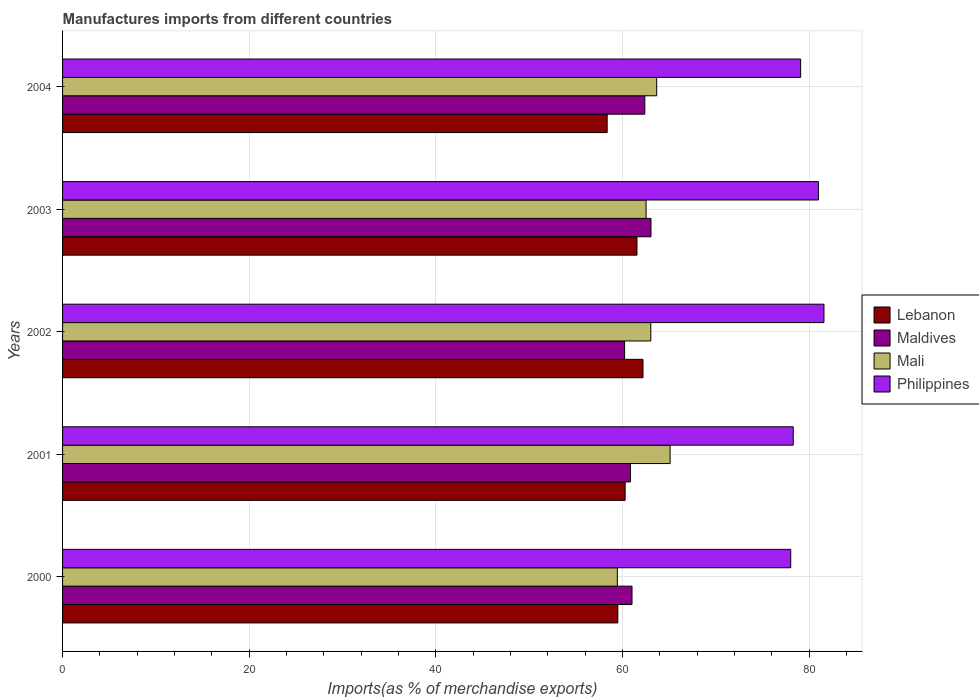How many different coloured bars are there?
Make the answer very short. 4. How many bars are there on the 3rd tick from the bottom?
Your answer should be very brief. 4. What is the percentage of imports to different countries in Mali in 2003?
Your response must be concise. 62.52. Across all years, what is the maximum percentage of imports to different countries in Lebanon?
Your answer should be very brief. 62.19. Across all years, what is the minimum percentage of imports to different countries in Mali?
Offer a terse response. 59.44. In which year was the percentage of imports to different countries in Maldives maximum?
Make the answer very short. 2003. What is the total percentage of imports to different countries in Mali in the graph?
Ensure brevity in your answer.  313.72. What is the difference between the percentage of imports to different countries in Maldives in 2000 and that in 2004?
Provide a short and direct response. -1.37. What is the difference between the percentage of imports to different countries in Philippines in 2003 and the percentage of imports to different countries in Mali in 2002?
Provide a short and direct response. 17.96. What is the average percentage of imports to different countries in Lebanon per year?
Offer a terse response. 60.37. In the year 2002, what is the difference between the percentage of imports to different countries in Philippines and percentage of imports to different countries in Maldives?
Provide a succinct answer. 21.36. In how many years, is the percentage of imports to different countries in Philippines greater than 64 %?
Offer a terse response. 5. What is the ratio of the percentage of imports to different countries in Maldives in 2001 to that in 2004?
Give a very brief answer. 0.98. Is the percentage of imports to different countries in Lebanon in 2001 less than that in 2003?
Your answer should be very brief. Yes. What is the difference between the highest and the second highest percentage of imports to different countries in Lebanon?
Provide a succinct answer. 0.65. What is the difference between the highest and the lowest percentage of imports to different countries in Maldives?
Offer a very short reply. 2.82. What does the 4th bar from the top in 2002 represents?
Make the answer very short. Lebanon. What does the 3rd bar from the bottom in 2002 represents?
Provide a short and direct response. Mali. Are all the bars in the graph horizontal?
Make the answer very short. Yes. Does the graph contain any zero values?
Your answer should be compact. No. Does the graph contain grids?
Ensure brevity in your answer.  Yes. Where does the legend appear in the graph?
Your answer should be very brief. Center right. How many legend labels are there?
Provide a short and direct response. 4. How are the legend labels stacked?
Your answer should be very brief. Vertical. What is the title of the graph?
Your answer should be very brief. Manufactures imports from different countries. Does "Least developed countries" appear as one of the legend labels in the graph?
Your answer should be very brief. No. What is the label or title of the X-axis?
Give a very brief answer. Imports(as % of merchandise exports). What is the Imports(as % of merchandise exports) in Lebanon in 2000?
Your answer should be compact. 59.49. What is the Imports(as % of merchandise exports) of Maldives in 2000?
Offer a terse response. 61.01. What is the Imports(as % of merchandise exports) of Mali in 2000?
Give a very brief answer. 59.44. What is the Imports(as % of merchandise exports) in Philippines in 2000?
Your answer should be very brief. 78.01. What is the Imports(as % of merchandise exports) in Lebanon in 2001?
Ensure brevity in your answer.  60.27. What is the Imports(as % of merchandise exports) of Maldives in 2001?
Ensure brevity in your answer.  60.84. What is the Imports(as % of merchandise exports) in Mali in 2001?
Ensure brevity in your answer.  65.09. What is the Imports(as % of merchandise exports) of Philippines in 2001?
Give a very brief answer. 78.28. What is the Imports(as % of merchandise exports) of Lebanon in 2002?
Provide a short and direct response. 62.19. What is the Imports(as % of merchandise exports) of Maldives in 2002?
Make the answer very short. 60.22. What is the Imports(as % of merchandise exports) in Mali in 2002?
Provide a short and direct response. 63.02. What is the Imports(as % of merchandise exports) in Philippines in 2002?
Provide a short and direct response. 81.57. What is the Imports(as % of merchandise exports) in Lebanon in 2003?
Offer a terse response. 61.54. What is the Imports(as % of merchandise exports) of Maldives in 2003?
Provide a short and direct response. 63.04. What is the Imports(as % of merchandise exports) in Mali in 2003?
Provide a short and direct response. 62.52. What is the Imports(as % of merchandise exports) of Philippines in 2003?
Make the answer very short. 80.98. What is the Imports(as % of merchandise exports) of Lebanon in 2004?
Your answer should be very brief. 58.35. What is the Imports(as % of merchandise exports) in Maldives in 2004?
Keep it short and to the point. 62.38. What is the Imports(as % of merchandise exports) in Mali in 2004?
Your answer should be very brief. 63.65. What is the Imports(as % of merchandise exports) in Philippines in 2004?
Your answer should be very brief. 79.07. Across all years, what is the maximum Imports(as % of merchandise exports) of Lebanon?
Offer a very short reply. 62.19. Across all years, what is the maximum Imports(as % of merchandise exports) in Maldives?
Your answer should be very brief. 63.04. Across all years, what is the maximum Imports(as % of merchandise exports) in Mali?
Give a very brief answer. 65.09. Across all years, what is the maximum Imports(as % of merchandise exports) in Philippines?
Provide a succinct answer. 81.57. Across all years, what is the minimum Imports(as % of merchandise exports) in Lebanon?
Your response must be concise. 58.35. Across all years, what is the minimum Imports(as % of merchandise exports) of Maldives?
Offer a terse response. 60.22. Across all years, what is the minimum Imports(as % of merchandise exports) in Mali?
Make the answer very short. 59.44. Across all years, what is the minimum Imports(as % of merchandise exports) of Philippines?
Offer a very short reply. 78.01. What is the total Imports(as % of merchandise exports) of Lebanon in the graph?
Provide a succinct answer. 301.83. What is the total Imports(as % of merchandise exports) in Maldives in the graph?
Give a very brief answer. 307.48. What is the total Imports(as % of merchandise exports) in Mali in the graph?
Make the answer very short. 313.72. What is the total Imports(as % of merchandise exports) of Philippines in the graph?
Ensure brevity in your answer.  397.92. What is the difference between the Imports(as % of merchandise exports) in Lebanon in 2000 and that in 2001?
Offer a terse response. -0.78. What is the difference between the Imports(as % of merchandise exports) of Maldives in 2000 and that in 2001?
Make the answer very short. 0.17. What is the difference between the Imports(as % of merchandise exports) in Mali in 2000 and that in 2001?
Ensure brevity in your answer.  -5.65. What is the difference between the Imports(as % of merchandise exports) in Philippines in 2000 and that in 2001?
Your response must be concise. -0.27. What is the difference between the Imports(as % of merchandise exports) of Lebanon in 2000 and that in 2002?
Keep it short and to the point. -2.7. What is the difference between the Imports(as % of merchandise exports) in Maldives in 2000 and that in 2002?
Provide a short and direct response. 0.79. What is the difference between the Imports(as % of merchandise exports) in Mali in 2000 and that in 2002?
Provide a short and direct response. -3.59. What is the difference between the Imports(as % of merchandise exports) in Philippines in 2000 and that in 2002?
Give a very brief answer. -3.56. What is the difference between the Imports(as % of merchandise exports) of Lebanon in 2000 and that in 2003?
Provide a succinct answer. -2.05. What is the difference between the Imports(as % of merchandise exports) in Maldives in 2000 and that in 2003?
Provide a succinct answer. -2.03. What is the difference between the Imports(as % of merchandise exports) of Mali in 2000 and that in 2003?
Ensure brevity in your answer.  -3.08. What is the difference between the Imports(as % of merchandise exports) in Philippines in 2000 and that in 2003?
Your answer should be compact. -2.97. What is the difference between the Imports(as % of merchandise exports) of Lebanon in 2000 and that in 2004?
Offer a very short reply. 1.14. What is the difference between the Imports(as % of merchandise exports) in Maldives in 2000 and that in 2004?
Keep it short and to the point. -1.37. What is the difference between the Imports(as % of merchandise exports) in Mali in 2000 and that in 2004?
Provide a succinct answer. -4.22. What is the difference between the Imports(as % of merchandise exports) of Philippines in 2000 and that in 2004?
Make the answer very short. -1.06. What is the difference between the Imports(as % of merchandise exports) of Lebanon in 2001 and that in 2002?
Ensure brevity in your answer.  -1.92. What is the difference between the Imports(as % of merchandise exports) in Maldives in 2001 and that in 2002?
Ensure brevity in your answer.  0.62. What is the difference between the Imports(as % of merchandise exports) of Mali in 2001 and that in 2002?
Provide a succinct answer. 2.07. What is the difference between the Imports(as % of merchandise exports) of Philippines in 2001 and that in 2002?
Provide a succinct answer. -3.29. What is the difference between the Imports(as % of merchandise exports) of Lebanon in 2001 and that in 2003?
Give a very brief answer. -1.27. What is the difference between the Imports(as % of merchandise exports) in Maldives in 2001 and that in 2003?
Offer a very short reply. -2.2. What is the difference between the Imports(as % of merchandise exports) in Mali in 2001 and that in 2003?
Keep it short and to the point. 2.57. What is the difference between the Imports(as % of merchandise exports) in Philippines in 2001 and that in 2003?
Keep it short and to the point. -2.7. What is the difference between the Imports(as % of merchandise exports) of Lebanon in 2001 and that in 2004?
Keep it short and to the point. 1.92. What is the difference between the Imports(as % of merchandise exports) in Maldives in 2001 and that in 2004?
Ensure brevity in your answer.  -1.54. What is the difference between the Imports(as % of merchandise exports) of Mali in 2001 and that in 2004?
Offer a very short reply. 1.44. What is the difference between the Imports(as % of merchandise exports) in Philippines in 2001 and that in 2004?
Offer a terse response. -0.79. What is the difference between the Imports(as % of merchandise exports) in Lebanon in 2002 and that in 2003?
Ensure brevity in your answer.  0.65. What is the difference between the Imports(as % of merchandise exports) of Maldives in 2002 and that in 2003?
Make the answer very short. -2.82. What is the difference between the Imports(as % of merchandise exports) of Mali in 2002 and that in 2003?
Offer a terse response. 0.51. What is the difference between the Imports(as % of merchandise exports) of Philippines in 2002 and that in 2003?
Your answer should be very brief. 0.59. What is the difference between the Imports(as % of merchandise exports) in Lebanon in 2002 and that in 2004?
Provide a succinct answer. 3.84. What is the difference between the Imports(as % of merchandise exports) of Maldives in 2002 and that in 2004?
Provide a short and direct response. -2.16. What is the difference between the Imports(as % of merchandise exports) in Mali in 2002 and that in 2004?
Your response must be concise. -0.63. What is the difference between the Imports(as % of merchandise exports) of Philippines in 2002 and that in 2004?
Offer a very short reply. 2.5. What is the difference between the Imports(as % of merchandise exports) of Lebanon in 2003 and that in 2004?
Your answer should be compact. 3.19. What is the difference between the Imports(as % of merchandise exports) in Maldives in 2003 and that in 2004?
Offer a terse response. 0.66. What is the difference between the Imports(as % of merchandise exports) in Mali in 2003 and that in 2004?
Your answer should be very brief. -1.14. What is the difference between the Imports(as % of merchandise exports) of Philippines in 2003 and that in 2004?
Provide a short and direct response. 1.9. What is the difference between the Imports(as % of merchandise exports) in Lebanon in 2000 and the Imports(as % of merchandise exports) in Maldives in 2001?
Your answer should be very brief. -1.35. What is the difference between the Imports(as % of merchandise exports) of Lebanon in 2000 and the Imports(as % of merchandise exports) of Mali in 2001?
Provide a succinct answer. -5.6. What is the difference between the Imports(as % of merchandise exports) of Lebanon in 2000 and the Imports(as % of merchandise exports) of Philippines in 2001?
Keep it short and to the point. -18.79. What is the difference between the Imports(as % of merchandise exports) in Maldives in 2000 and the Imports(as % of merchandise exports) in Mali in 2001?
Provide a short and direct response. -4.08. What is the difference between the Imports(as % of merchandise exports) of Maldives in 2000 and the Imports(as % of merchandise exports) of Philippines in 2001?
Offer a terse response. -17.27. What is the difference between the Imports(as % of merchandise exports) of Mali in 2000 and the Imports(as % of merchandise exports) of Philippines in 2001?
Keep it short and to the point. -18.84. What is the difference between the Imports(as % of merchandise exports) of Lebanon in 2000 and the Imports(as % of merchandise exports) of Maldives in 2002?
Your response must be concise. -0.73. What is the difference between the Imports(as % of merchandise exports) in Lebanon in 2000 and the Imports(as % of merchandise exports) in Mali in 2002?
Ensure brevity in your answer.  -3.53. What is the difference between the Imports(as % of merchandise exports) of Lebanon in 2000 and the Imports(as % of merchandise exports) of Philippines in 2002?
Provide a short and direct response. -22.09. What is the difference between the Imports(as % of merchandise exports) of Maldives in 2000 and the Imports(as % of merchandise exports) of Mali in 2002?
Your response must be concise. -2.01. What is the difference between the Imports(as % of merchandise exports) of Maldives in 2000 and the Imports(as % of merchandise exports) of Philippines in 2002?
Your answer should be very brief. -20.57. What is the difference between the Imports(as % of merchandise exports) of Mali in 2000 and the Imports(as % of merchandise exports) of Philippines in 2002?
Offer a very short reply. -22.14. What is the difference between the Imports(as % of merchandise exports) of Lebanon in 2000 and the Imports(as % of merchandise exports) of Maldives in 2003?
Make the answer very short. -3.55. What is the difference between the Imports(as % of merchandise exports) in Lebanon in 2000 and the Imports(as % of merchandise exports) in Mali in 2003?
Keep it short and to the point. -3.03. What is the difference between the Imports(as % of merchandise exports) of Lebanon in 2000 and the Imports(as % of merchandise exports) of Philippines in 2003?
Provide a short and direct response. -21.49. What is the difference between the Imports(as % of merchandise exports) of Maldives in 2000 and the Imports(as % of merchandise exports) of Mali in 2003?
Provide a short and direct response. -1.51. What is the difference between the Imports(as % of merchandise exports) of Maldives in 2000 and the Imports(as % of merchandise exports) of Philippines in 2003?
Your response must be concise. -19.97. What is the difference between the Imports(as % of merchandise exports) in Mali in 2000 and the Imports(as % of merchandise exports) in Philippines in 2003?
Your answer should be compact. -21.54. What is the difference between the Imports(as % of merchandise exports) in Lebanon in 2000 and the Imports(as % of merchandise exports) in Maldives in 2004?
Make the answer very short. -2.89. What is the difference between the Imports(as % of merchandise exports) of Lebanon in 2000 and the Imports(as % of merchandise exports) of Mali in 2004?
Keep it short and to the point. -4.16. What is the difference between the Imports(as % of merchandise exports) of Lebanon in 2000 and the Imports(as % of merchandise exports) of Philippines in 2004?
Provide a short and direct response. -19.59. What is the difference between the Imports(as % of merchandise exports) in Maldives in 2000 and the Imports(as % of merchandise exports) in Mali in 2004?
Your answer should be very brief. -2.64. What is the difference between the Imports(as % of merchandise exports) of Maldives in 2000 and the Imports(as % of merchandise exports) of Philippines in 2004?
Ensure brevity in your answer.  -18.07. What is the difference between the Imports(as % of merchandise exports) in Mali in 2000 and the Imports(as % of merchandise exports) in Philippines in 2004?
Make the answer very short. -19.64. What is the difference between the Imports(as % of merchandise exports) in Lebanon in 2001 and the Imports(as % of merchandise exports) in Maldives in 2002?
Give a very brief answer. 0.05. What is the difference between the Imports(as % of merchandise exports) of Lebanon in 2001 and the Imports(as % of merchandise exports) of Mali in 2002?
Provide a short and direct response. -2.75. What is the difference between the Imports(as % of merchandise exports) in Lebanon in 2001 and the Imports(as % of merchandise exports) in Philippines in 2002?
Give a very brief answer. -21.3. What is the difference between the Imports(as % of merchandise exports) in Maldives in 2001 and the Imports(as % of merchandise exports) in Mali in 2002?
Provide a short and direct response. -2.18. What is the difference between the Imports(as % of merchandise exports) of Maldives in 2001 and the Imports(as % of merchandise exports) of Philippines in 2002?
Keep it short and to the point. -20.74. What is the difference between the Imports(as % of merchandise exports) of Mali in 2001 and the Imports(as % of merchandise exports) of Philippines in 2002?
Your answer should be very brief. -16.48. What is the difference between the Imports(as % of merchandise exports) in Lebanon in 2001 and the Imports(as % of merchandise exports) in Maldives in 2003?
Offer a terse response. -2.77. What is the difference between the Imports(as % of merchandise exports) of Lebanon in 2001 and the Imports(as % of merchandise exports) of Mali in 2003?
Offer a terse response. -2.25. What is the difference between the Imports(as % of merchandise exports) in Lebanon in 2001 and the Imports(as % of merchandise exports) in Philippines in 2003?
Your answer should be very brief. -20.71. What is the difference between the Imports(as % of merchandise exports) in Maldives in 2001 and the Imports(as % of merchandise exports) in Mali in 2003?
Keep it short and to the point. -1.68. What is the difference between the Imports(as % of merchandise exports) in Maldives in 2001 and the Imports(as % of merchandise exports) in Philippines in 2003?
Provide a short and direct response. -20.14. What is the difference between the Imports(as % of merchandise exports) in Mali in 2001 and the Imports(as % of merchandise exports) in Philippines in 2003?
Ensure brevity in your answer.  -15.89. What is the difference between the Imports(as % of merchandise exports) of Lebanon in 2001 and the Imports(as % of merchandise exports) of Maldives in 2004?
Make the answer very short. -2.11. What is the difference between the Imports(as % of merchandise exports) in Lebanon in 2001 and the Imports(as % of merchandise exports) in Mali in 2004?
Your answer should be compact. -3.38. What is the difference between the Imports(as % of merchandise exports) of Lebanon in 2001 and the Imports(as % of merchandise exports) of Philippines in 2004?
Offer a terse response. -18.8. What is the difference between the Imports(as % of merchandise exports) of Maldives in 2001 and the Imports(as % of merchandise exports) of Mali in 2004?
Make the answer very short. -2.81. What is the difference between the Imports(as % of merchandise exports) of Maldives in 2001 and the Imports(as % of merchandise exports) of Philippines in 2004?
Your answer should be very brief. -18.24. What is the difference between the Imports(as % of merchandise exports) of Mali in 2001 and the Imports(as % of merchandise exports) of Philippines in 2004?
Keep it short and to the point. -13.99. What is the difference between the Imports(as % of merchandise exports) of Lebanon in 2002 and the Imports(as % of merchandise exports) of Maldives in 2003?
Your answer should be compact. -0.85. What is the difference between the Imports(as % of merchandise exports) in Lebanon in 2002 and the Imports(as % of merchandise exports) in Mali in 2003?
Give a very brief answer. -0.33. What is the difference between the Imports(as % of merchandise exports) of Lebanon in 2002 and the Imports(as % of merchandise exports) of Philippines in 2003?
Offer a terse response. -18.79. What is the difference between the Imports(as % of merchandise exports) of Maldives in 2002 and the Imports(as % of merchandise exports) of Mali in 2003?
Ensure brevity in your answer.  -2.3. What is the difference between the Imports(as % of merchandise exports) of Maldives in 2002 and the Imports(as % of merchandise exports) of Philippines in 2003?
Give a very brief answer. -20.76. What is the difference between the Imports(as % of merchandise exports) in Mali in 2002 and the Imports(as % of merchandise exports) in Philippines in 2003?
Ensure brevity in your answer.  -17.96. What is the difference between the Imports(as % of merchandise exports) in Lebanon in 2002 and the Imports(as % of merchandise exports) in Maldives in 2004?
Your answer should be very brief. -0.19. What is the difference between the Imports(as % of merchandise exports) in Lebanon in 2002 and the Imports(as % of merchandise exports) in Mali in 2004?
Provide a succinct answer. -1.47. What is the difference between the Imports(as % of merchandise exports) of Lebanon in 2002 and the Imports(as % of merchandise exports) of Philippines in 2004?
Your answer should be very brief. -16.89. What is the difference between the Imports(as % of merchandise exports) of Maldives in 2002 and the Imports(as % of merchandise exports) of Mali in 2004?
Make the answer very short. -3.44. What is the difference between the Imports(as % of merchandise exports) of Maldives in 2002 and the Imports(as % of merchandise exports) of Philippines in 2004?
Your answer should be compact. -18.86. What is the difference between the Imports(as % of merchandise exports) of Mali in 2002 and the Imports(as % of merchandise exports) of Philippines in 2004?
Give a very brief answer. -16.05. What is the difference between the Imports(as % of merchandise exports) of Lebanon in 2003 and the Imports(as % of merchandise exports) of Maldives in 2004?
Ensure brevity in your answer.  -0.84. What is the difference between the Imports(as % of merchandise exports) in Lebanon in 2003 and the Imports(as % of merchandise exports) in Mali in 2004?
Offer a very short reply. -2.11. What is the difference between the Imports(as % of merchandise exports) of Lebanon in 2003 and the Imports(as % of merchandise exports) of Philippines in 2004?
Your answer should be very brief. -17.53. What is the difference between the Imports(as % of merchandise exports) in Maldives in 2003 and the Imports(as % of merchandise exports) in Mali in 2004?
Your answer should be compact. -0.61. What is the difference between the Imports(as % of merchandise exports) of Maldives in 2003 and the Imports(as % of merchandise exports) of Philippines in 2004?
Your answer should be very brief. -16.03. What is the difference between the Imports(as % of merchandise exports) of Mali in 2003 and the Imports(as % of merchandise exports) of Philippines in 2004?
Ensure brevity in your answer.  -16.56. What is the average Imports(as % of merchandise exports) of Lebanon per year?
Your response must be concise. 60.37. What is the average Imports(as % of merchandise exports) in Maldives per year?
Provide a succinct answer. 61.5. What is the average Imports(as % of merchandise exports) in Mali per year?
Your answer should be compact. 62.74. What is the average Imports(as % of merchandise exports) in Philippines per year?
Give a very brief answer. 79.58. In the year 2000, what is the difference between the Imports(as % of merchandise exports) in Lebanon and Imports(as % of merchandise exports) in Maldives?
Offer a very short reply. -1.52. In the year 2000, what is the difference between the Imports(as % of merchandise exports) of Lebanon and Imports(as % of merchandise exports) of Mali?
Offer a very short reply. 0.05. In the year 2000, what is the difference between the Imports(as % of merchandise exports) in Lebanon and Imports(as % of merchandise exports) in Philippines?
Make the answer very short. -18.52. In the year 2000, what is the difference between the Imports(as % of merchandise exports) in Maldives and Imports(as % of merchandise exports) in Mali?
Give a very brief answer. 1.57. In the year 2000, what is the difference between the Imports(as % of merchandise exports) in Maldives and Imports(as % of merchandise exports) in Philippines?
Keep it short and to the point. -17. In the year 2000, what is the difference between the Imports(as % of merchandise exports) in Mali and Imports(as % of merchandise exports) in Philippines?
Your response must be concise. -18.58. In the year 2001, what is the difference between the Imports(as % of merchandise exports) of Lebanon and Imports(as % of merchandise exports) of Maldives?
Offer a terse response. -0.57. In the year 2001, what is the difference between the Imports(as % of merchandise exports) of Lebanon and Imports(as % of merchandise exports) of Mali?
Your response must be concise. -4.82. In the year 2001, what is the difference between the Imports(as % of merchandise exports) in Lebanon and Imports(as % of merchandise exports) in Philippines?
Make the answer very short. -18.01. In the year 2001, what is the difference between the Imports(as % of merchandise exports) in Maldives and Imports(as % of merchandise exports) in Mali?
Give a very brief answer. -4.25. In the year 2001, what is the difference between the Imports(as % of merchandise exports) of Maldives and Imports(as % of merchandise exports) of Philippines?
Provide a succinct answer. -17.44. In the year 2001, what is the difference between the Imports(as % of merchandise exports) in Mali and Imports(as % of merchandise exports) in Philippines?
Ensure brevity in your answer.  -13.19. In the year 2002, what is the difference between the Imports(as % of merchandise exports) in Lebanon and Imports(as % of merchandise exports) in Maldives?
Keep it short and to the point. 1.97. In the year 2002, what is the difference between the Imports(as % of merchandise exports) in Lebanon and Imports(as % of merchandise exports) in Mali?
Keep it short and to the point. -0.84. In the year 2002, what is the difference between the Imports(as % of merchandise exports) in Lebanon and Imports(as % of merchandise exports) in Philippines?
Provide a succinct answer. -19.39. In the year 2002, what is the difference between the Imports(as % of merchandise exports) of Maldives and Imports(as % of merchandise exports) of Mali?
Ensure brevity in your answer.  -2.81. In the year 2002, what is the difference between the Imports(as % of merchandise exports) of Maldives and Imports(as % of merchandise exports) of Philippines?
Your answer should be very brief. -21.36. In the year 2002, what is the difference between the Imports(as % of merchandise exports) in Mali and Imports(as % of merchandise exports) in Philippines?
Provide a short and direct response. -18.55. In the year 2003, what is the difference between the Imports(as % of merchandise exports) in Lebanon and Imports(as % of merchandise exports) in Maldives?
Your answer should be compact. -1.5. In the year 2003, what is the difference between the Imports(as % of merchandise exports) of Lebanon and Imports(as % of merchandise exports) of Mali?
Your answer should be very brief. -0.98. In the year 2003, what is the difference between the Imports(as % of merchandise exports) in Lebanon and Imports(as % of merchandise exports) in Philippines?
Ensure brevity in your answer.  -19.44. In the year 2003, what is the difference between the Imports(as % of merchandise exports) in Maldives and Imports(as % of merchandise exports) in Mali?
Provide a short and direct response. 0.52. In the year 2003, what is the difference between the Imports(as % of merchandise exports) in Maldives and Imports(as % of merchandise exports) in Philippines?
Keep it short and to the point. -17.94. In the year 2003, what is the difference between the Imports(as % of merchandise exports) of Mali and Imports(as % of merchandise exports) of Philippines?
Provide a succinct answer. -18.46. In the year 2004, what is the difference between the Imports(as % of merchandise exports) in Lebanon and Imports(as % of merchandise exports) in Maldives?
Provide a succinct answer. -4.03. In the year 2004, what is the difference between the Imports(as % of merchandise exports) of Lebanon and Imports(as % of merchandise exports) of Mali?
Provide a succinct answer. -5.31. In the year 2004, what is the difference between the Imports(as % of merchandise exports) of Lebanon and Imports(as % of merchandise exports) of Philippines?
Your answer should be compact. -20.73. In the year 2004, what is the difference between the Imports(as % of merchandise exports) of Maldives and Imports(as % of merchandise exports) of Mali?
Your answer should be very brief. -1.27. In the year 2004, what is the difference between the Imports(as % of merchandise exports) in Maldives and Imports(as % of merchandise exports) in Philippines?
Offer a very short reply. -16.69. In the year 2004, what is the difference between the Imports(as % of merchandise exports) in Mali and Imports(as % of merchandise exports) in Philippines?
Give a very brief answer. -15.42. What is the ratio of the Imports(as % of merchandise exports) in Mali in 2000 to that in 2001?
Your answer should be very brief. 0.91. What is the ratio of the Imports(as % of merchandise exports) of Philippines in 2000 to that in 2001?
Give a very brief answer. 1. What is the ratio of the Imports(as % of merchandise exports) of Lebanon in 2000 to that in 2002?
Make the answer very short. 0.96. What is the ratio of the Imports(as % of merchandise exports) of Maldives in 2000 to that in 2002?
Ensure brevity in your answer.  1.01. What is the ratio of the Imports(as % of merchandise exports) of Mali in 2000 to that in 2002?
Provide a succinct answer. 0.94. What is the ratio of the Imports(as % of merchandise exports) of Philippines in 2000 to that in 2002?
Offer a terse response. 0.96. What is the ratio of the Imports(as % of merchandise exports) of Lebanon in 2000 to that in 2003?
Your response must be concise. 0.97. What is the ratio of the Imports(as % of merchandise exports) in Maldives in 2000 to that in 2003?
Provide a short and direct response. 0.97. What is the ratio of the Imports(as % of merchandise exports) of Mali in 2000 to that in 2003?
Provide a short and direct response. 0.95. What is the ratio of the Imports(as % of merchandise exports) in Philippines in 2000 to that in 2003?
Ensure brevity in your answer.  0.96. What is the ratio of the Imports(as % of merchandise exports) of Lebanon in 2000 to that in 2004?
Your answer should be very brief. 1.02. What is the ratio of the Imports(as % of merchandise exports) of Mali in 2000 to that in 2004?
Your answer should be compact. 0.93. What is the ratio of the Imports(as % of merchandise exports) of Philippines in 2000 to that in 2004?
Offer a very short reply. 0.99. What is the ratio of the Imports(as % of merchandise exports) in Lebanon in 2001 to that in 2002?
Your response must be concise. 0.97. What is the ratio of the Imports(as % of merchandise exports) of Maldives in 2001 to that in 2002?
Your response must be concise. 1.01. What is the ratio of the Imports(as % of merchandise exports) of Mali in 2001 to that in 2002?
Ensure brevity in your answer.  1.03. What is the ratio of the Imports(as % of merchandise exports) in Philippines in 2001 to that in 2002?
Offer a very short reply. 0.96. What is the ratio of the Imports(as % of merchandise exports) in Lebanon in 2001 to that in 2003?
Ensure brevity in your answer.  0.98. What is the ratio of the Imports(as % of merchandise exports) of Maldives in 2001 to that in 2003?
Offer a very short reply. 0.97. What is the ratio of the Imports(as % of merchandise exports) in Mali in 2001 to that in 2003?
Your response must be concise. 1.04. What is the ratio of the Imports(as % of merchandise exports) in Philippines in 2001 to that in 2003?
Offer a very short reply. 0.97. What is the ratio of the Imports(as % of merchandise exports) in Lebanon in 2001 to that in 2004?
Ensure brevity in your answer.  1.03. What is the ratio of the Imports(as % of merchandise exports) of Maldives in 2001 to that in 2004?
Your response must be concise. 0.98. What is the ratio of the Imports(as % of merchandise exports) of Mali in 2001 to that in 2004?
Give a very brief answer. 1.02. What is the ratio of the Imports(as % of merchandise exports) of Philippines in 2001 to that in 2004?
Your answer should be compact. 0.99. What is the ratio of the Imports(as % of merchandise exports) of Lebanon in 2002 to that in 2003?
Offer a terse response. 1.01. What is the ratio of the Imports(as % of merchandise exports) of Maldives in 2002 to that in 2003?
Ensure brevity in your answer.  0.96. What is the ratio of the Imports(as % of merchandise exports) in Mali in 2002 to that in 2003?
Offer a very short reply. 1.01. What is the ratio of the Imports(as % of merchandise exports) of Philippines in 2002 to that in 2003?
Your answer should be compact. 1.01. What is the ratio of the Imports(as % of merchandise exports) of Lebanon in 2002 to that in 2004?
Your answer should be very brief. 1.07. What is the ratio of the Imports(as % of merchandise exports) of Maldives in 2002 to that in 2004?
Ensure brevity in your answer.  0.97. What is the ratio of the Imports(as % of merchandise exports) of Philippines in 2002 to that in 2004?
Keep it short and to the point. 1.03. What is the ratio of the Imports(as % of merchandise exports) of Lebanon in 2003 to that in 2004?
Give a very brief answer. 1.05. What is the ratio of the Imports(as % of merchandise exports) in Maldives in 2003 to that in 2004?
Offer a very short reply. 1.01. What is the ratio of the Imports(as % of merchandise exports) in Mali in 2003 to that in 2004?
Keep it short and to the point. 0.98. What is the ratio of the Imports(as % of merchandise exports) of Philippines in 2003 to that in 2004?
Provide a short and direct response. 1.02. What is the difference between the highest and the second highest Imports(as % of merchandise exports) of Lebanon?
Your answer should be compact. 0.65. What is the difference between the highest and the second highest Imports(as % of merchandise exports) of Maldives?
Offer a very short reply. 0.66. What is the difference between the highest and the second highest Imports(as % of merchandise exports) in Mali?
Offer a very short reply. 1.44. What is the difference between the highest and the second highest Imports(as % of merchandise exports) of Philippines?
Your answer should be compact. 0.59. What is the difference between the highest and the lowest Imports(as % of merchandise exports) in Lebanon?
Make the answer very short. 3.84. What is the difference between the highest and the lowest Imports(as % of merchandise exports) in Maldives?
Your response must be concise. 2.82. What is the difference between the highest and the lowest Imports(as % of merchandise exports) of Mali?
Offer a very short reply. 5.65. What is the difference between the highest and the lowest Imports(as % of merchandise exports) of Philippines?
Give a very brief answer. 3.56. 